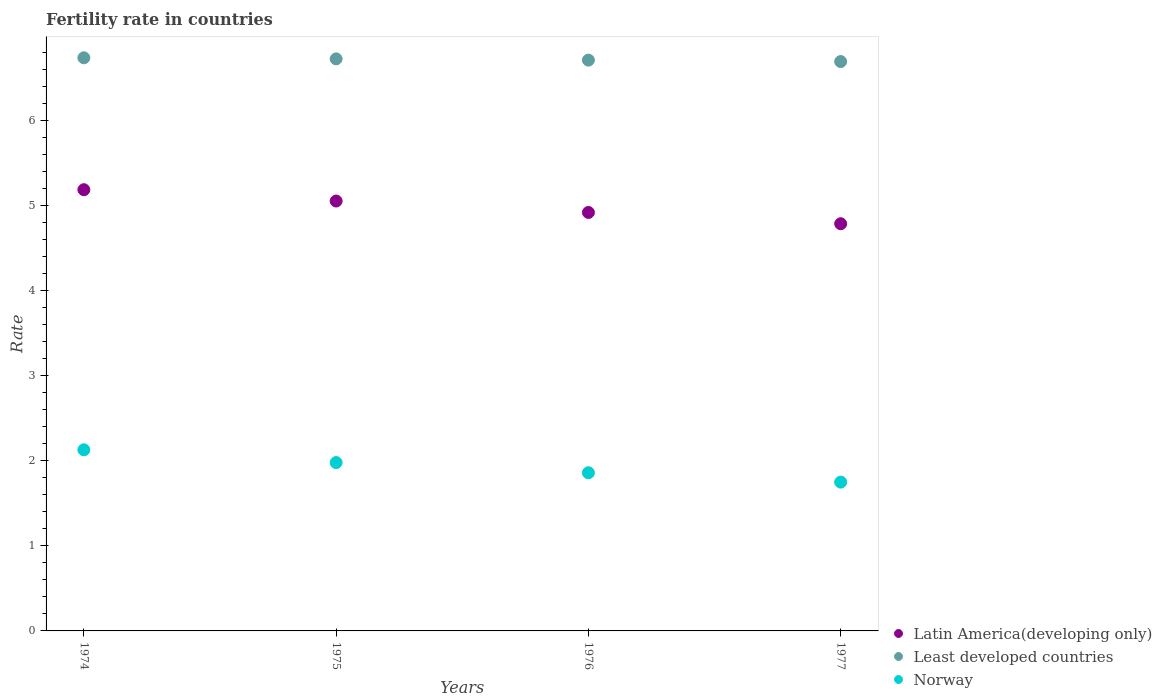What is the fertility rate in Least developed countries in 1975?
Give a very brief answer. 6.73. Across all years, what is the maximum fertility rate in Latin America(developing only)?
Your answer should be very brief. 5.19. Across all years, what is the minimum fertility rate in Least developed countries?
Give a very brief answer. 6.7. In which year was the fertility rate in Latin America(developing only) maximum?
Make the answer very short. 1974. In which year was the fertility rate in Least developed countries minimum?
Offer a terse response. 1977. What is the total fertility rate in Norway in the graph?
Ensure brevity in your answer.  7.72. What is the difference between the fertility rate in Least developed countries in 1976 and that in 1977?
Ensure brevity in your answer.  0.02. What is the difference between the fertility rate in Least developed countries in 1976 and the fertility rate in Norway in 1977?
Provide a short and direct response. 4.96. What is the average fertility rate in Latin America(developing only) per year?
Offer a very short reply. 4.99. In the year 1975, what is the difference between the fertility rate in Least developed countries and fertility rate in Latin America(developing only)?
Your answer should be very brief. 1.67. What is the ratio of the fertility rate in Latin America(developing only) in 1975 to that in 1976?
Ensure brevity in your answer.  1.03. Is the difference between the fertility rate in Least developed countries in 1974 and 1977 greater than the difference between the fertility rate in Latin America(developing only) in 1974 and 1977?
Give a very brief answer. No. What is the difference between the highest and the second highest fertility rate in Least developed countries?
Keep it short and to the point. 0.01. What is the difference between the highest and the lowest fertility rate in Norway?
Keep it short and to the point. 0.38. In how many years, is the fertility rate in Least developed countries greater than the average fertility rate in Least developed countries taken over all years?
Provide a succinct answer. 2. Is it the case that in every year, the sum of the fertility rate in Least developed countries and fertility rate in Latin America(developing only)  is greater than the fertility rate in Norway?
Offer a very short reply. Yes. Is the fertility rate in Least developed countries strictly less than the fertility rate in Latin America(developing only) over the years?
Provide a succinct answer. No. What is the difference between two consecutive major ticks on the Y-axis?
Your answer should be compact. 1. How many legend labels are there?
Your response must be concise. 3. How are the legend labels stacked?
Your answer should be very brief. Vertical. What is the title of the graph?
Provide a succinct answer. Fertility rate in countries. Does "Hungary" appear as one of the legend labels in the graph?
Your response must be concise. No. What is the label or title of the Y-axis?
Your answer should be very brief. Rate. What is the Rate of Latin America(developing only) in 1974?
Make the answer very short. 5.19. What is the Rate of Least developed countries in 1974?
Keep it short and to the point. 6.74. What is the Rate of Norway in 1974?
Your answer should be compact. 2.13. What is the Rate in Latin America(developing only) in 1975?
Ensure brevity in your answer.  5.06. What is the Rate in Least developed countries in 1975?
Give a very brief answer. 6.73. What is the Rate of Norway in 1975?
Make the answer very short. 1.98. What is the Rate in Latin America(developing only) in 1976?
Provide a succinct answer. 4.92. What is the Rate in Least developed countries in 1976?
Offer a terse response. 6.71. What is the Rate in Norway in 1976?
Offer a terse response. 1.86. What is the Rate in Latin America(developing only) in 1977?
Give a very brief answer. 4.79. What is the Rate in Least developed countries in 1977?
Keep it short and to the point. 6.7. Across all years, what is the maximum Rate of Latin America(developing only)?
Your response must be concise. 5.19. Across all years, what is the maximum Rate of Least developed countries?
Ensure brevity in your answer.  6.74. Across all years, what is the maximum Rate of Norway?
Offer a terse response. 2.13. Across all years, what is the minimum Rate in Latin America(developing only)?
Your answer should be compact. 4.79. Across all years, what is the minimum Rate of Least developed countries?
Ensure brevity in your answer.  6.7. What is the total Rate in Latin America(developing only) in the graph?
Offer a terse response. 19.95. What is the total Rate of Least developed countries in the graph?
Keep it short and to the point. 26.88. What is the total Rate in Norway in the graph?
Offer a terse response. 7.72. What is the difference between the Rate of Latin America(developing only) in 1974 and that in 1975?
Make the answer very short. 0.13. What is the difference between the Rate of Least developed countries in 1974 and that in 1975?
Offer a terse response. 0.01. What is the difference between the Rate of Latin America(developing only) in 1974 and that in 1976?
Your response must be concise. 0.27. What is the difference between the Rate of Least developed countries in 1974 and that in 1976?
Your response must be concise. 0.03. What is the difference between the Rate of Norway in 1974 and that in 1976?
Give a very brief answer. 0.27. What is the difference between the Rate of Latin America(developing only) in 1974 and that in 1977?
Ensure brevity in your answer.  0.4. What is the difference between the Rate in Least developed countries in 1974 and that in 1977?
Offer a terse response. 0.04. What is the difference between the Rate in Norway in 1974 and that in 1977?
Your response must be concise. 0.38. What is the difference between the Rate in Latin America(developing only) in 1975 and that in 1976?
Offer a terse response. 0.13. What is the difference between the Rate of Least developed countries in 1975 and that in 1976?
Ensure brevity in your answer.  0.01. What is the difference between the Rate in Norway in 1975 and that in 1976?
Provide a succinct answer. 0.12. What is the difference between the Rate of Latin America(developing only) in 1975 and that in 1977?
Offer a terse response. 0.27. What is the difference between the Rate in Least developed countries in 1975 and that in 1977?
Your answer should be compact. 0.03. What is the difference between the Rate in Norway in 1975 and that in 1977?
Keep it short and to the point. 0.23. What is the difference between the Rate in Latin America(developing only) in 1976 and that in 1977?
Your answer should be very brief. 0.13. What is the difference between the Rate of Least developed countries in 1976 and that in 1977?
Give a very brief answer. 0.02. What is the difference between the Rate in Norway in 1976 and that in 1977?
Keep it short and to the point. 0.11. What is the difference between the Rate in Latin America(developing only) in 1974 and the Rate in Least developed countries in 1975?
Make the answer very short. -1.54. What is the difference between the Rate of Latin America(developing only) in 1974 and the Rate of Norway in 1975?
Make the answer very short. 3.21. What is the difference between the Rate of Least developed countries in 1974 and the Rate of Norway in 1975?
Make the answer very short. 4.76. What is the difference between the Rate of Latin America(developing only) in 1974 and the Rate of Least developed countries in 1976?
Make the answer very short. -1.52. What is the difference between the Rate of Latin America(developing only) in 1974 and the Rate of Norway in 1976?
Ensure brevity in your answer.  3.33. What is the difference between the Rate of Least developed countries in 1974 and the Rate of Norway in 1976?
Your answer should be very brief. 4.88. What is the difference between the Rate in Latin America(developing only) in 1974 and the Rate in Least developed countries in 1977?
Keep it short and to the point. -1.51. What is the difference between the Rate of Latin America(developing only) in 1974 and the Rate of Norway in 1977?
Provide a short and direct response. 3.44. What is the difference between the Rate in Least developed countries in 1974 and the Rate in Norway in 1977?
Make the answer very short. 4.99. What is the difference between the Rate in Latin America(developing only) in 1975 and the Rate in Least developed countries in 1976?
Give a very brief answer. -1.66. What is the difference between the Rate in Latin America(developing only) in 1975 and the Rate in Norway in 1976?
Your answer should be compact. 3.2. What is the difference between the Rate of Least developed countries in 1975 and the Rate of Norway in 1976?
Ensure brevity in your answer.  4.87. What is the difference between the Rate of Latin America(developing only) in 1975 and the Rate of Least developed countries in 1977?
Your answer should be very brief. -1.64. What is the difference between the Rate of Latin America(developing only) in 1975 and the Rate of Norway in 1977?
Make the answer very short. 3.31. What is the difference between the Rate in Least developed countries in 1975 and the Rate in Norway in 1977?
Make the answer very short. 4.98. What is the difference between the Rate in Latin America(developing only) in 1976 and the Rate in Least developed countries in 1977?
Give a very brief answer. -1.77. What is the difference between the Rate of Latin America(developing only) in 1976 and the Rate of Norway in 1977?
Ensure brevity in your answer.  3.17. What is the difference between the Rate in Least developed countries in 1976 and the Rate in Norway in 1977?
Make the answer very short. 4.96. What is the average Rate of Latin America(developing only) per year?
Give a very brief answer. 4.99. What is the average Rate in Least developed countries per year?
Offer a terse response. 6.72. What is the average Rate in Norway per year?
Your response must be concise. 1.93. In the year 1974, what is the difference between the Rate in Latin America(developing only) and Rate in Least developed countries?
Provide a succinct answer. -1.55. In the year 1974, what is the difference between the Rate of Latin America(developing only) and Rate of Norway?
Provide a short and direct response. 3.06. In the year 1974, what is the difference between the Rate of Least developed countries and Rate of Norway?
Give a very brief answer. 4.61. In the year 1975, what is the difference between the Rate of Latin America(developing only) and Rate of Least developed countries?
Provide a succinct answer. -1.67. In the year 1975, what is the difference between the Rate of Latin America(developing only) and Rate of Norway?
Your response must be concise. 3.08. In the year 1975, what is the difference between the Rate of Least developed countries and Rate of Norway?
Ensure brevity in your answer.  4.75. In the year 1976, what is the difference between the Rate in Latin America(developing only) and Rate in Least developed countries?
Keep it short and to the point. -1.79. In the year 1976, what is the difference between the Rate in Latin America(developing only) and Rate in Norway?
Ensure brevity in your answer.  3.06. In the year 1976, what is the difference between the Rate of Least developed countries and Rate of Norway?
Your answer should be compact. 4.85. In the year 1977, what is the difference between the Rate in Latin America(developing only) and Rate in Least developed countries?
Your answer should be very brief. -1.91. In the year 1977, what is the difference between the Rate in Latin America(developing only) and Rate in Norway?
Keep it short and to the point. 3.04. In the year 1977, what is the difference between the Rate in Least developed countries and Rate in Norway?
Your response must be concise. 4.95. What is the ratio of the Rate in Latin America(developing only) in 1974 to that in 1975?
Give a very brief answer. 1.03. What is the ratio of the Rate of Norway in 1974 to that in 1975?
Offer a very short reply. 1.08. What is the ratio of the Rate of Latin America(developing only) in 1974 to that in 1976?
Your response must be concise. 1.05. What is the ratio of the Rate in Least developed countries in 1974 to that in 1976?
Your answer should be very brief. 1. What is the ratio of the Rate in Norway in 1974 to that in 1976?
Your response must be concise. 1.15. What is the ratio of the Rate of Latin America(developing only) in 1974 to that in 1977?
Give a very brief answer. 1.08. What is the ratio of the Rate of Least developed countries in 1974 to that in 1977?
Provide a succinct answer. 1.01. What is the ratio of the Rate of Norway in 1974 to that in 1977?
Your answer should be very brief. 1.22. What is the ratio of the Rate of Latin America(developing only) in 1975 to that in 1976?
Offer a very short reply. 1.03. What is the ratio of the Rate in Norway in 1975 to that in 1976?
Offer a terse response. 1.06. What is the ratio of the Rate of Latin America(developing only) in 1975 to that in 1977?
Make the answer very short. 1.06. What is the ratio of the Rate of Norway in 1975 to that in 1977?
Provide a succinct answer. 1.13. What is the ratio of the Rate in Latin America(developing only) in 1976 to that in 1977?
Give a very brief answer. 1.03. What is the ratio of the Rate in Norway in 1976 to that in 1977?
Ensure brevity in your answer.  1.06. What is the difference between the highest and the second highest Rate in Latin America(developing only)?
Make the answer very short. 0.13. What is the difference between the highest and the second highest Rate in Least developed countries?
Your response must be concise. 0.01. What is the difference between the highest and the lowest Rate in Latin America(developing only)?
Offer a terse response. 0.4. What is the difference between the highest and the lowest Rate in Least developed countries?
Provide a short and direct response. 0.04. What is the difference between the highest and the lowest Rate of Norway?
Give a very brief answer. 0.38. 